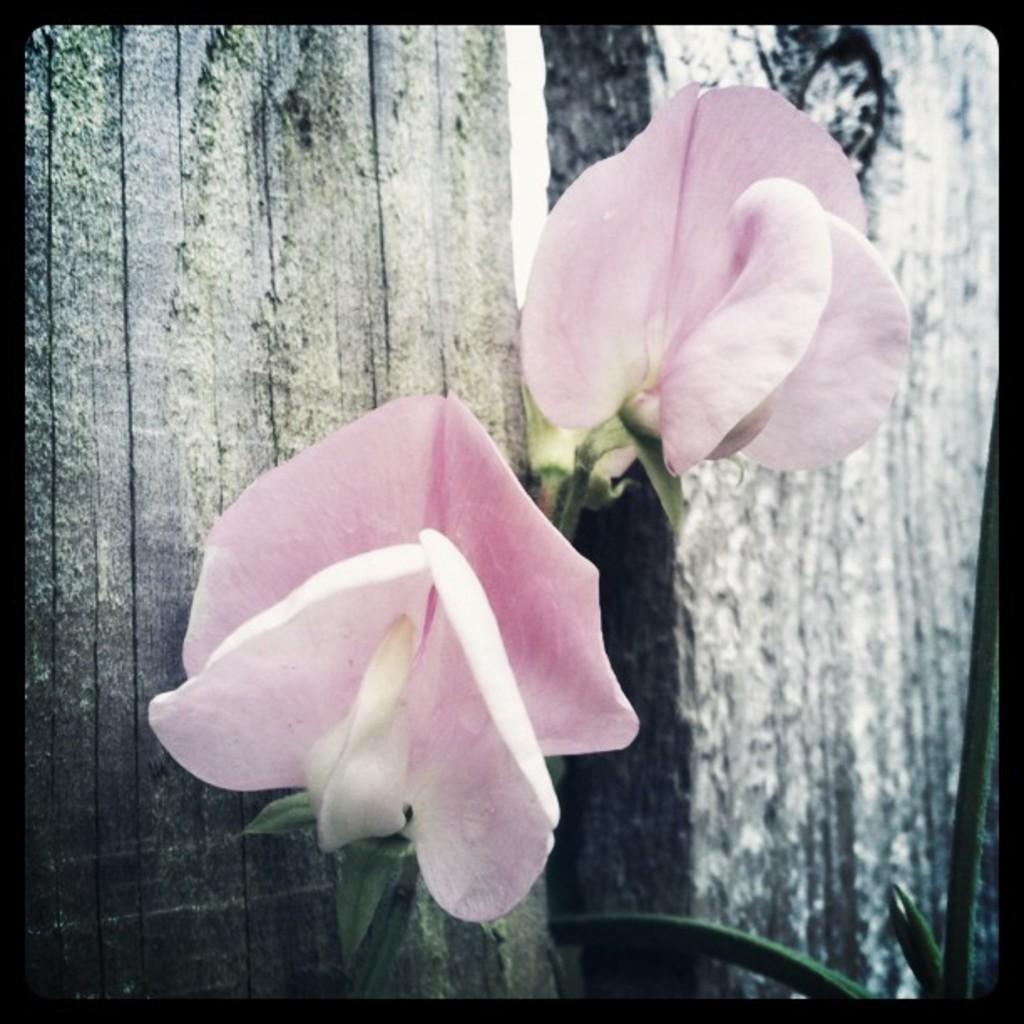Describe this image in one or two sentences. In this image I see 2 flowers which are of pink in color and I see the green color thing over here. 